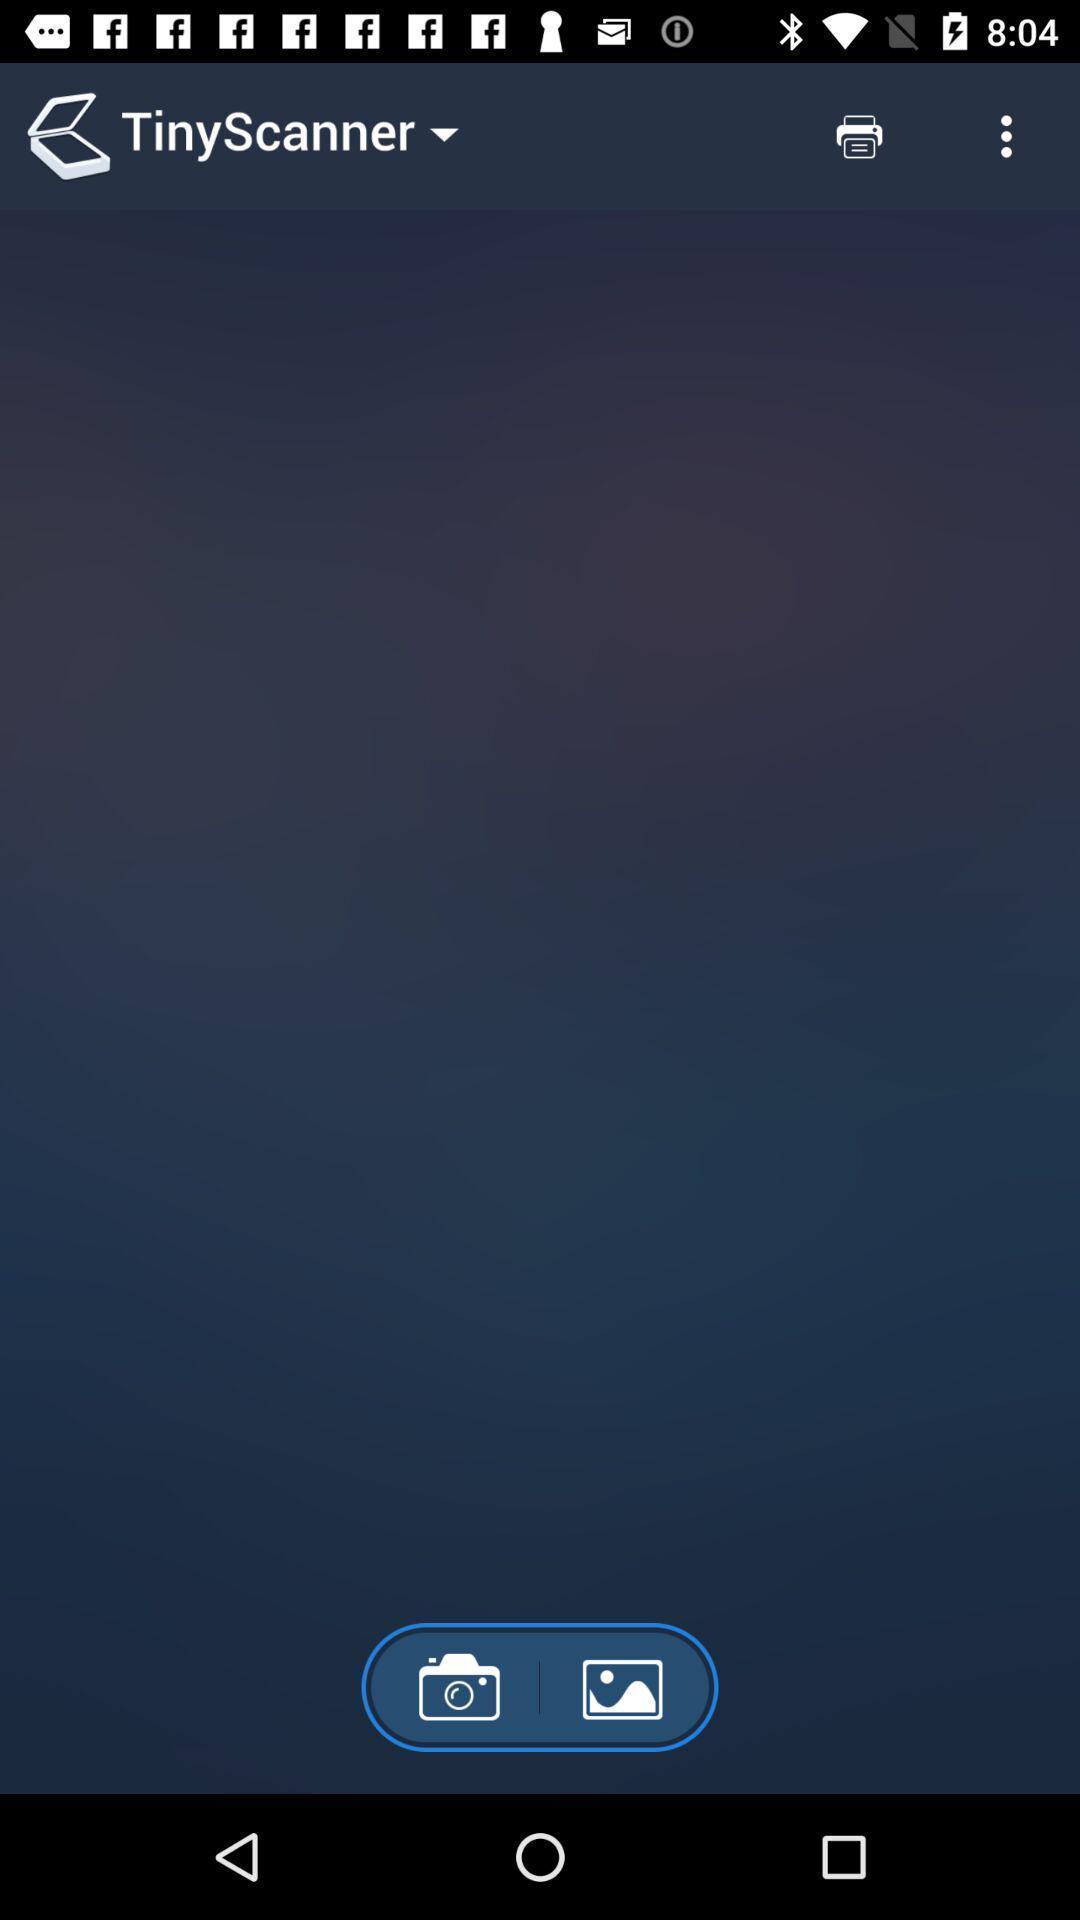Explain what's happening in this screen capture. Page for scanning images and folders of a scanning app. 